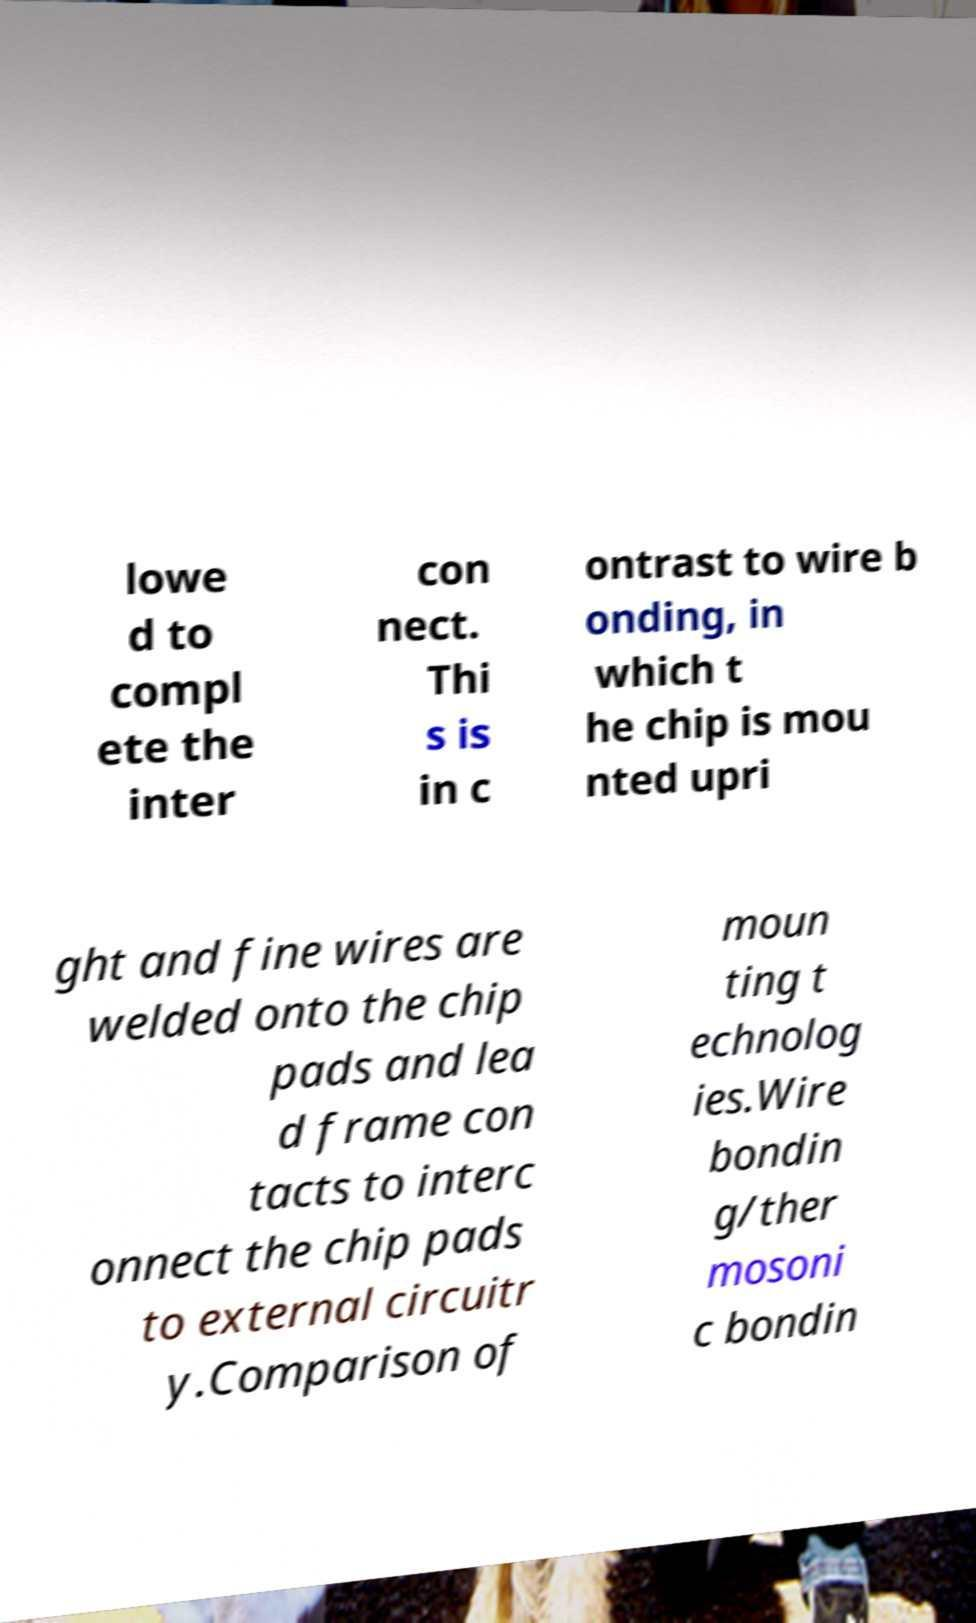What messages or text are displayed in this image? I need them in a readable, typed format. lowe d to compl ete the inter con nect. Thi s is in c ontrast to wire b onding, in which t he chip is mou nted upri ght and fine wires are welded onto the chip pads and lea d frame con tacts to interc onnect the chip pads to external circuitr y.Comparison of moun ting t echnolog ies.Wire bondin g/ther mosoni c bondin 